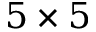<formula> <loc_0><loc_0><loc_500><loc_500>5 \times 5</formula> 